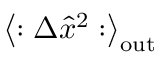Convert formula to latex. <formula><loc_0><loc_0><loc_500><loc_500>\left \langle \colon \Delta \hat { x } ^ { 2 } \colon \right \rangle _ { o u t }</formula> 